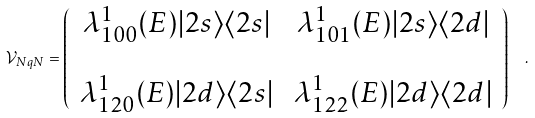Convert formula to latex. <formula><loc_0><loc_0><loc_500><loc_500>\mathcal { V } _ { N q N } = \left ( \begin{array} { c c } \lambda ^ { 1 } _ { 1 0 0 } ( E ) | 2 s \rangle \langle 2 s | & \, \lambda ^ { 1 } _ { 1 0 1 } ( E ) | 2 s \rangle \langle 2 d | \\ \\ \lambda ^ { 1 } _ { 1 2 0 } ( E ) | 2 d \rangle \langle 2 s | & \, \lambda ^ { 1 } _ { 1 2 2 } ( E ) | 2 d \rangle \langle 2 d | \end{array} \right ) \ \ .</formula> 